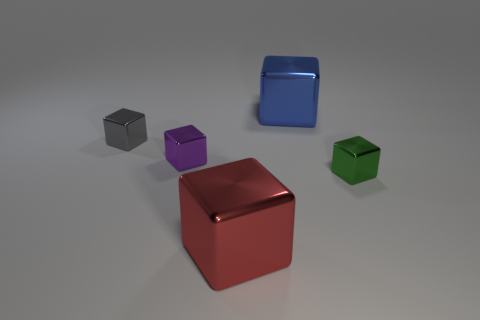Subtract all purple cubes. How many cubes are left? 4 Subtract all small gray shiny cubes. How many cubes are left? 4 Subtract all red blocks. Subtract all brown spheres. How many blocks are left? 4 Add 4 cyan matte spheres. How many objects exist? 9 Add 1 blue objects. How many blue objects are left? 2 Add 2 big cyan balls. How many big cyan balls exist? 2 Subtract 0 red cylinders. How many objects are left? 5 Subtract all tiny gray things. Subtract all red things. How many objects are left? 3 